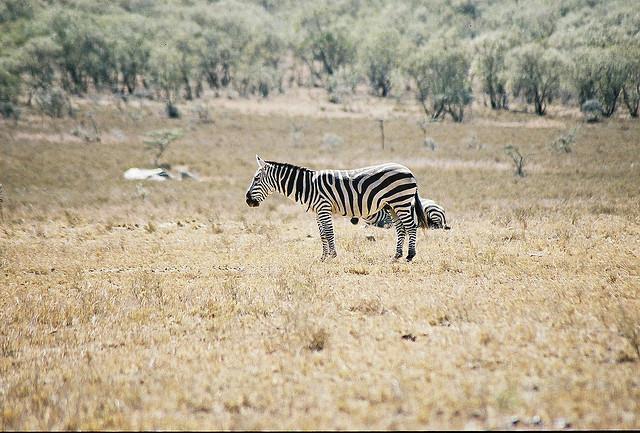How many zebra are there?
Give a very brief answer. 2. How many zebras can be seen?
Give a very brief answer. 2. 